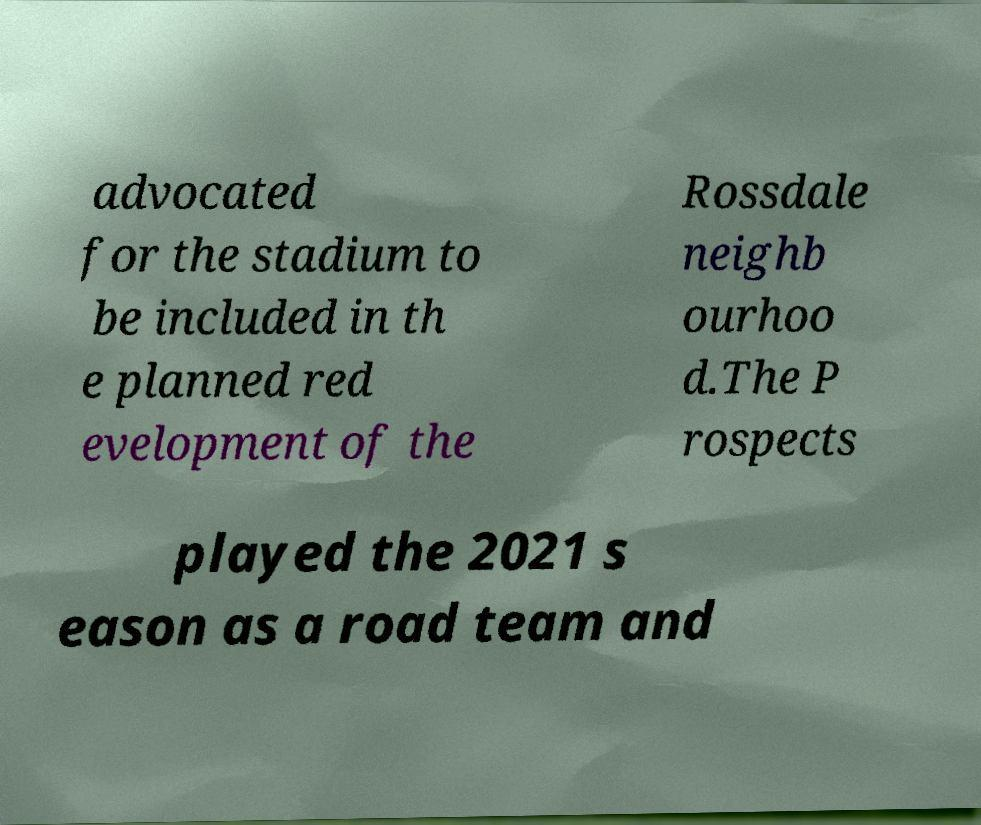Can you read and provide the text displayed in the image?This photo seems to have some interesting text. Can you extract and type it out for me? advocated for the stadium to be included in th e planned red evelopment of the Rossdale neighb ourhoo d.The P rospects played the 2021 s eason as a road team and 